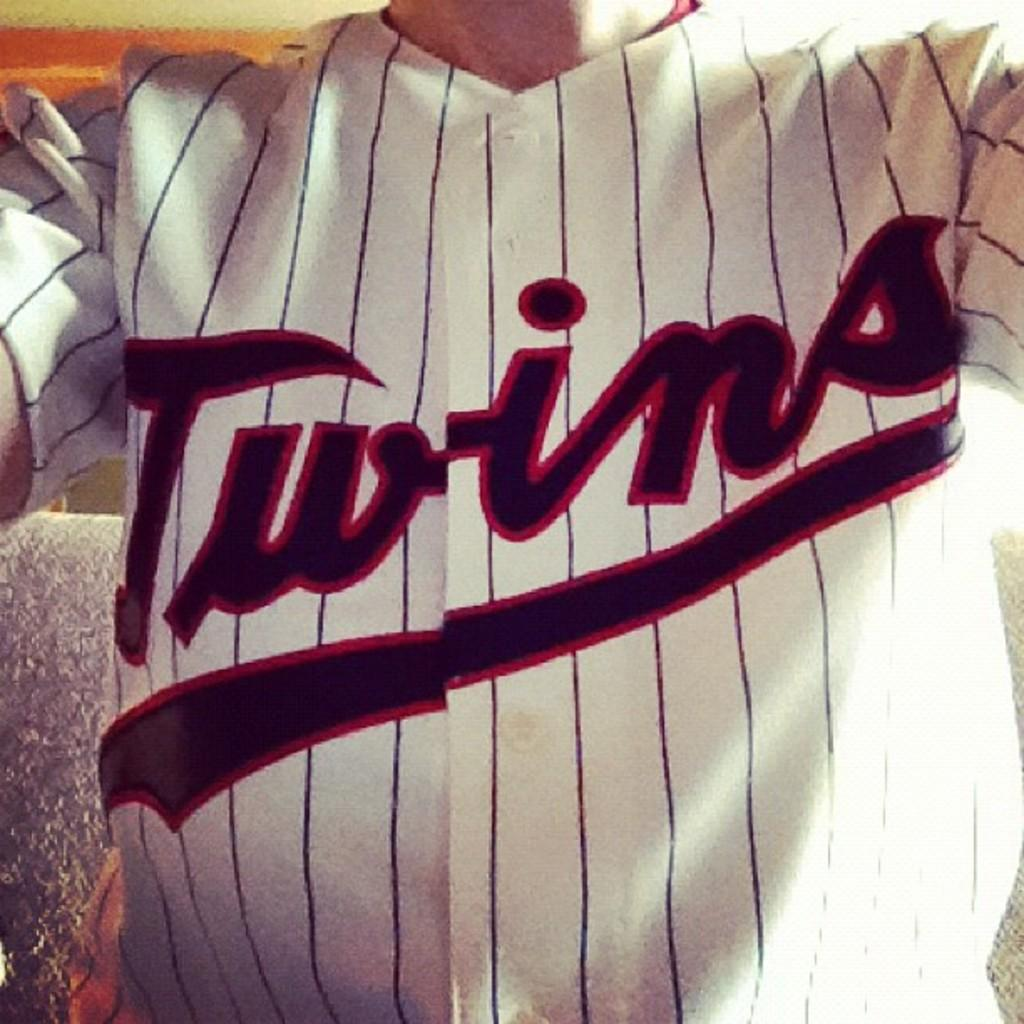What is the main subject of the image? There is a person in the image. What is the person wearing? The person is wearing a white shirt. Where is the person located in the image? The person is located in the center of the image. What type of event is the person attending in the image? There is no indication of an event in the image; it only shows a person wearing a white shirt and located in the center. How much wealth does the person have in the image? There is no information about the person's wealth in the image. 